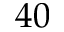<formula> <loc_0><loc_0><loc_500><loc_500>4 0</formula> 